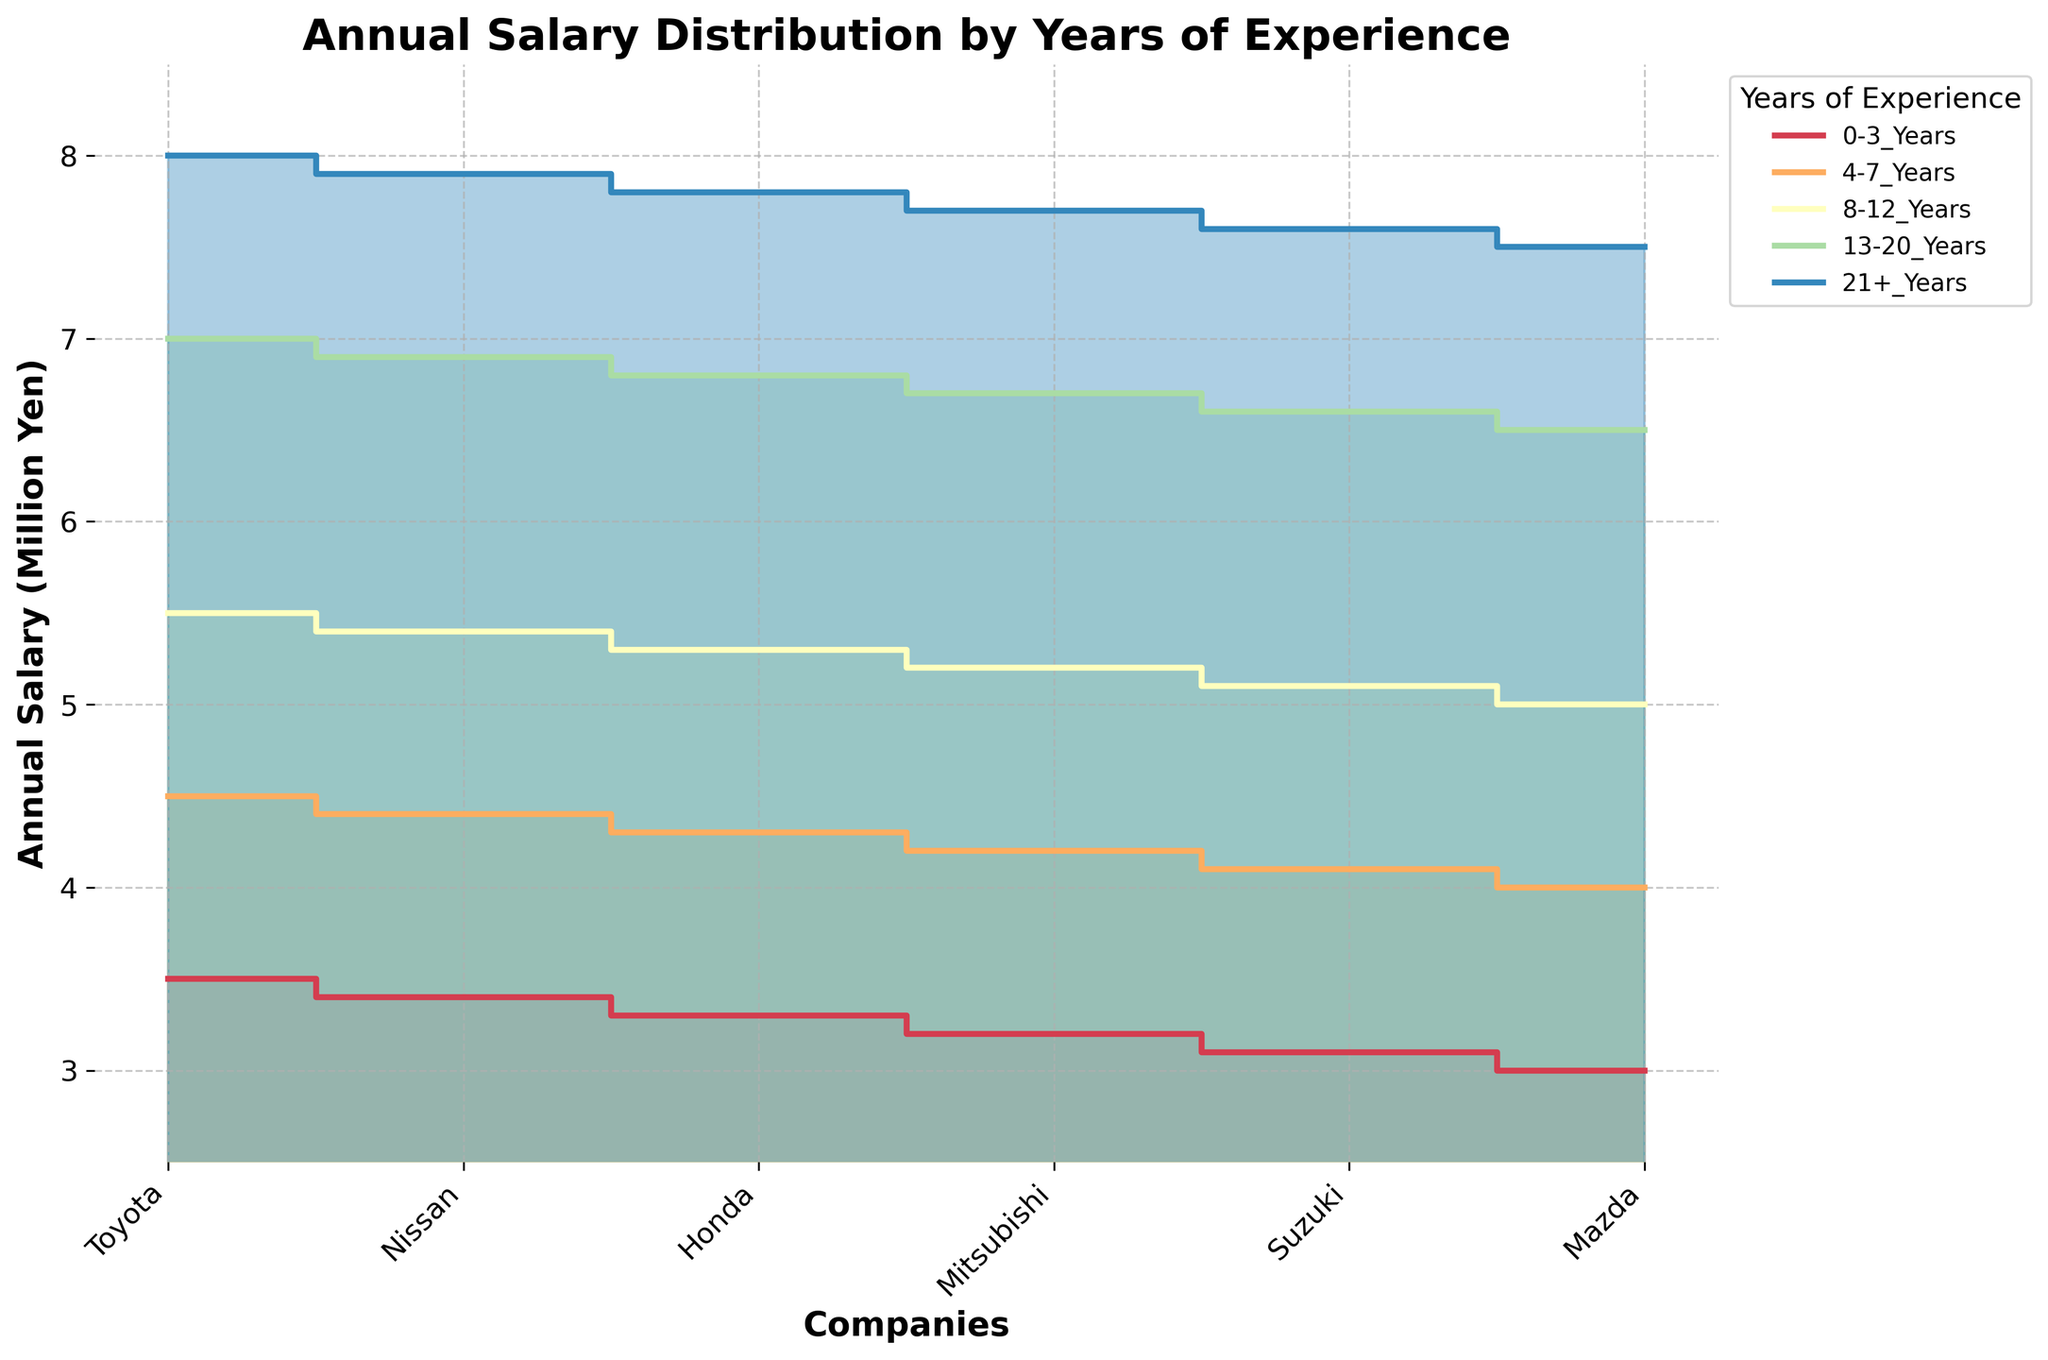What is the title of the chart? The title is found at the top of the chart and is clearly indicated in bold.
Answer: Annual Salary Distribution by Years of Experience Which company has the lowest starting salary for employees with 0-3 years of experience? By looking at the leftmost points of the chart for '0-3_Years', the line at the lowest position shows the lowest salary.
Answer: Mazda What is the average salary for Honda employees with 8-12 years of experience? First find the salary for Honda with 8-12 years of experience. It is 5.3 million yen. Since there is only one data point, the average is the same as the value.
Answer: 5.3 million yen How much higher is Toyota's salary compared to Nissan's for employees with 13-20 years of experience? Identify Toyota's salary for 13-20 years (7 million yen) and Nissan's salary for 13-20 years (6.9 million yen). Subtract Nissan's salary from Toyota's salary.
Answer: 0.1 million yen Which company shows the most consistent increase in salary across experience levels? Consistency can be judged by looking at the smoothness and gradual slope of the lines representing each company.
Answer: Toyota For which years of experience is the salary for Suzuki employees closest to Honda's? Look for the points where the two lines for Suzuki and Honda almost touch or are very close.
Answer: 8-12 Years What is the range of annual salary for Mitsubishi employees? Find the minimum salary (3.2 million yen for 0-3 years) and the maximum salary (6.7 million yen for 13-20 years) for Mitsubishi. The range is the difference between these values.
Answer: 3.5 million yen For which companies does the annual salary exceed 7 million yen for employees with 13-20 years of experience? Identify the companies where the salary line for 13-20 years experience is above 7 million yen.
Answer: None What is the total annual salary for employees with 8-12 years of experience across all companies? Sum up the salaries for 8-12 years of experience of all companies: 5.5 + 5.4 + 5.3 + 5.2 + 5.1 + 5 (all in millions).
Answer: 32.5 million yen Which experience level sees the biggest salary increase from the previous level for Nissan? Compare the increase between each established level (e.g., from 0-3 to 4-7 years). The largest jump will give the answer.
Answer: 0-3 Years to 4-7 Years 